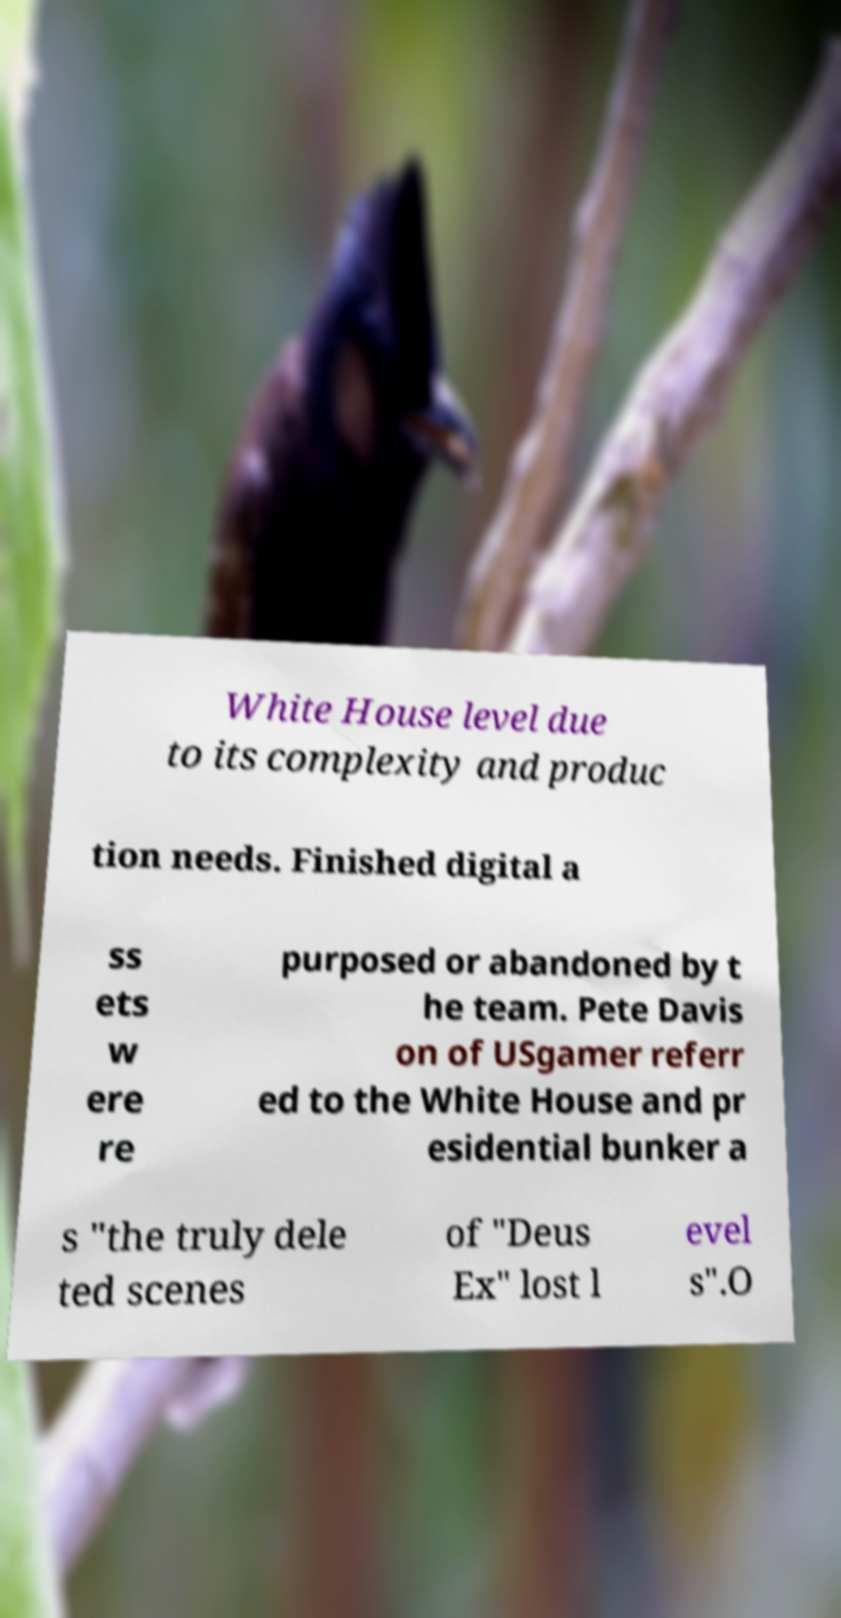What messages or text are displayed in this image? I need them in a readable, typed format. White House level due to its complexity and produc tion needs. Finished digital a ss ets w ere re purposed or abandoned by t he team. Pete Davis on of USgamer referr ed to the White House and pr esidential bunker a s "the truly dele ted scenes of "Deus Ex" lost l evel s".O 